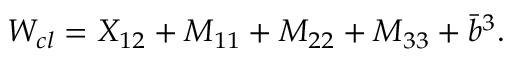Convert formula to latex. <formula><loc_0><loc_0><loc_500><loc_500>W _ { c l } = X _ { 1 2 } + M _ { 1 1 } + M _ { 2 2 } + M _ { 3 3 } + \bar { b } ^ { 3 } .</formula> 